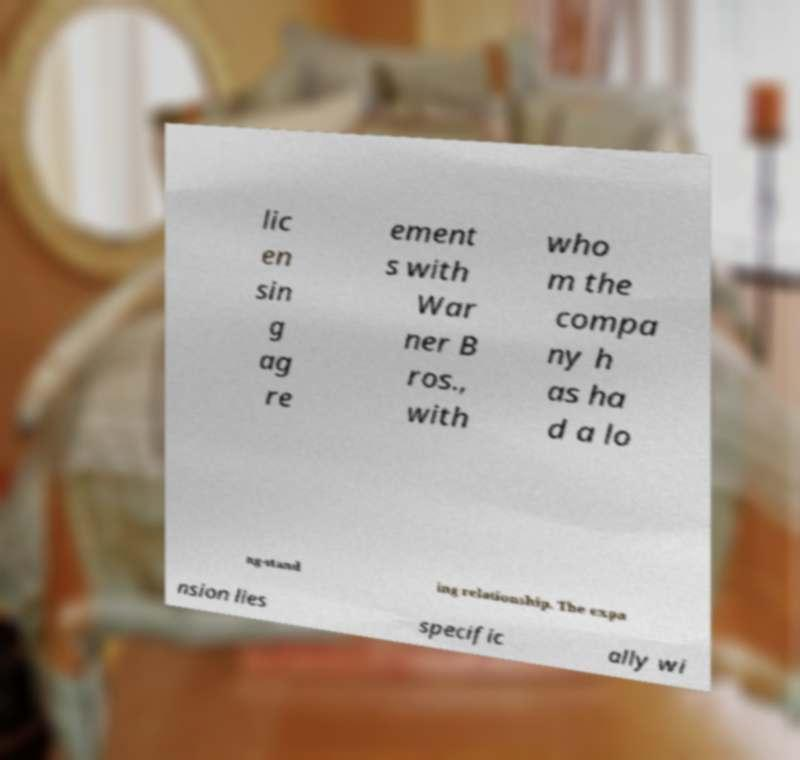Please identify and transcribe the text found in this image. lic en sin g ag re ement s with War ner B ros., with who m the compa ny h as ha d a lo ng-stand ing relationship. The expa nsion lies specific ally wi 